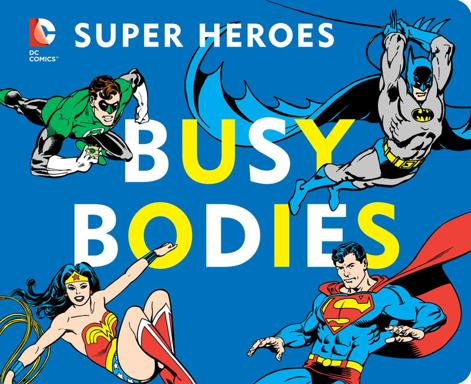What is the main theme of the objects mentioned in the image? The main theme depicted in the image centers around iconic DC superheroes, including Batman, Superman, Wonder Woman, and others, portrayed in a vibrant and dynamic style reminiscent of classic comic book art. 